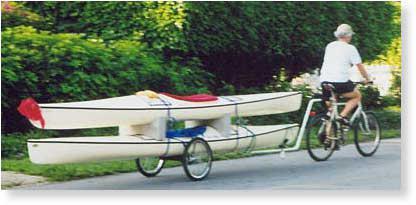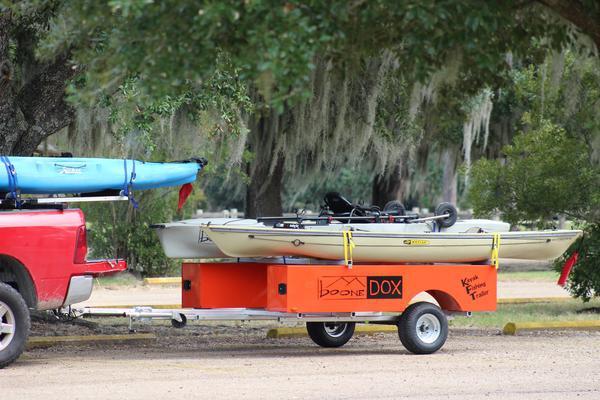The first image is the image on the left, the second image is the image on the right. Given the left and right images, does the statement "An image of a trailer includes two boats and a bicycle." hold true? Answer yes or no. Yes. The first image is the image on the left, the second image is the image on the right. For the images displayed, is the sentence "The bike is connected to the trailer carrying the canoes." factually correct? Answer yes or no. Yes. 